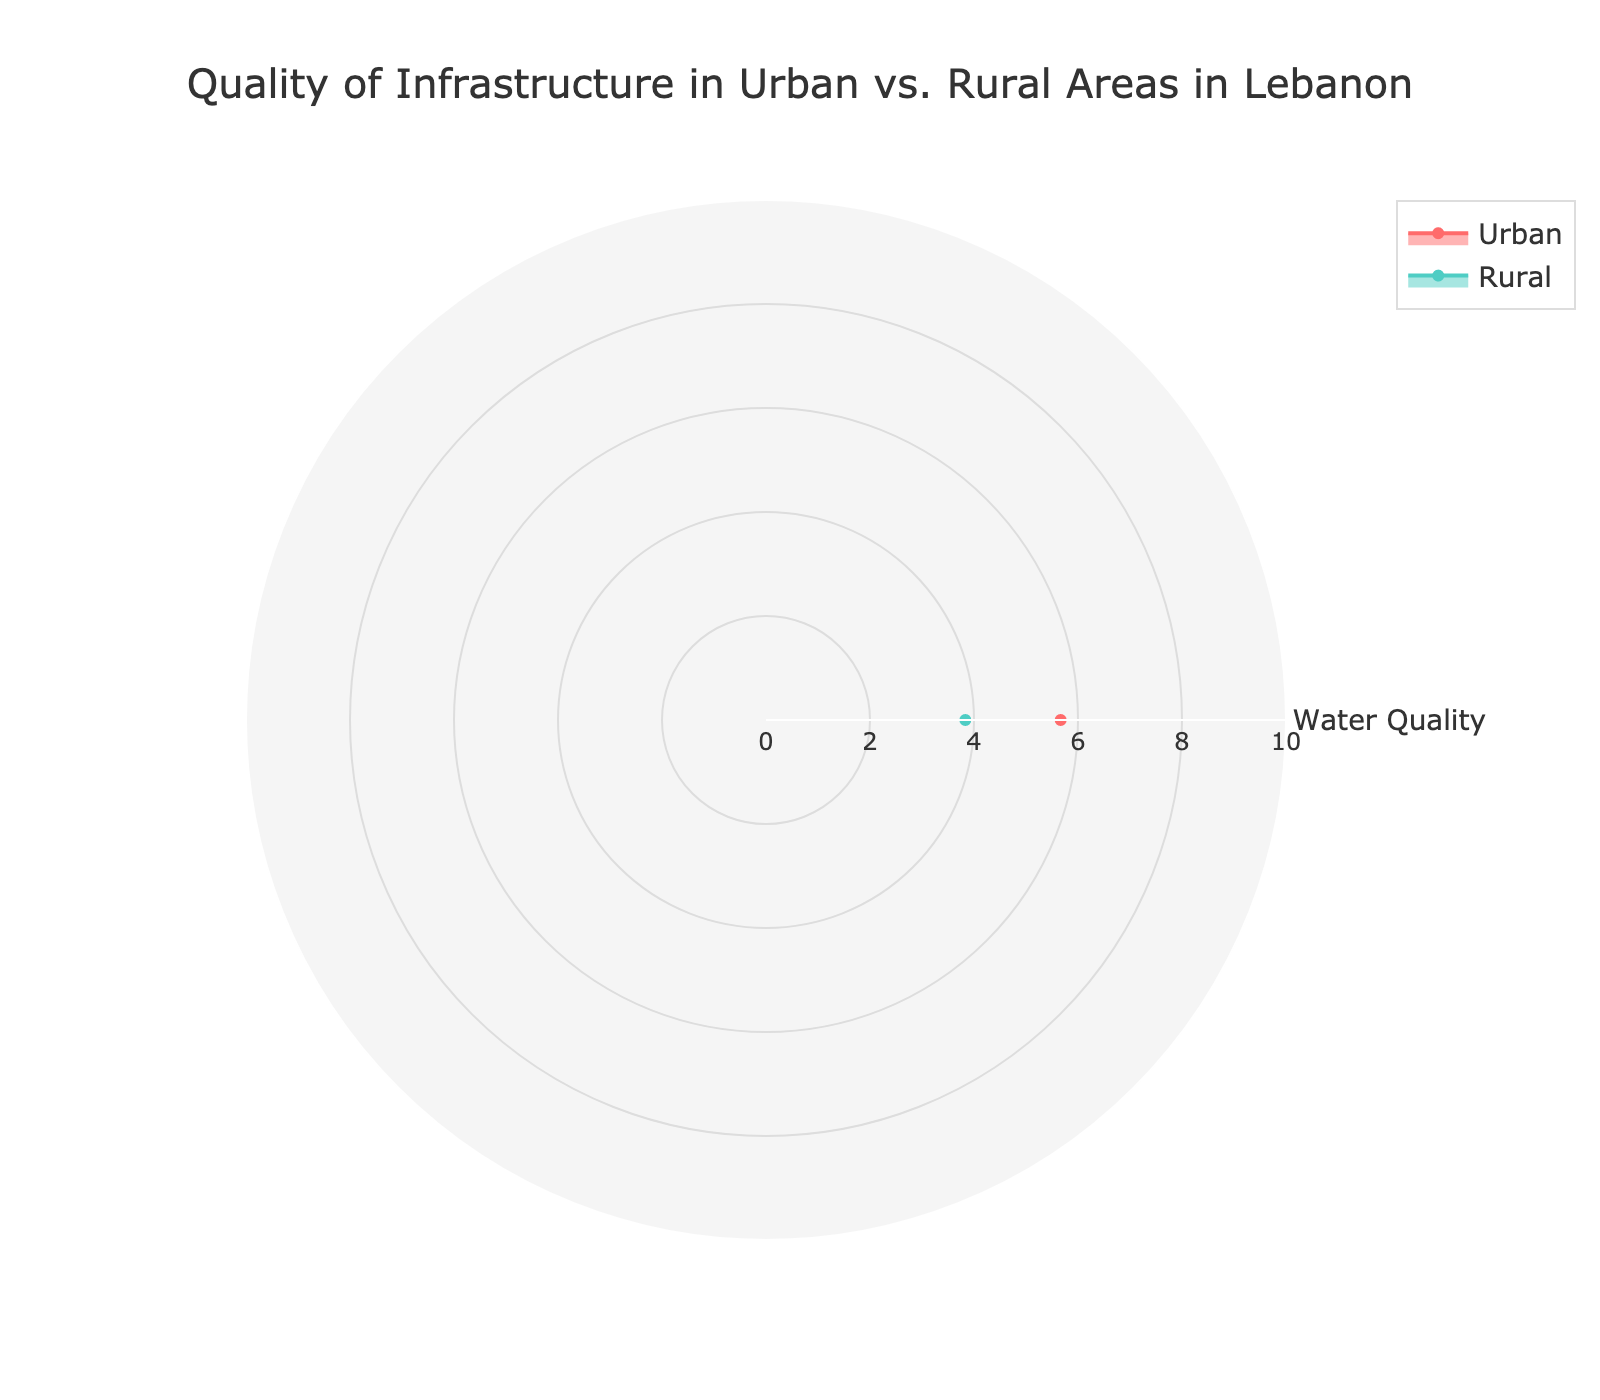What is the title of the figure? The title of the figure is written at the top and specifies what the chart is about, which is "Quality of Infrastructure in Urban vs. Rural Areas in Lebanon".
Answer: Quality of Infrastructure in Urban vs. Rural Areas in Lebanon Which area has the higher average water quality, urban or rural? To determine this, compare the water quality values for urban and rural areas as displayed on the radar chart.
Answer: Urban What is the average Electricity Reliability for rural areas? To find the average, look at the radar chart section for rural areas and note the value indicated for Electricity Reliability.
Answer: 5.83 Which category shows the smallest difference in quality between urban and rural areas? Examine each category (Water Quality, Electricity Reliability, Road Quality) on the radar chart and compare the lengths of the values for urban and rural areas. The smallest difference will be the least noticeable gap.
Answer: Electricity Reliability What is the overall shape of the radar chart for urban areas compared to rural areas? The radar chart's overall shape for each area (urban and rural) can be observed from the filled regions. The urban area's shape extends more widely, indicating generally higher values.
Answer: Urban extends more widely How does the quality of roads in rural areas compare to urban areas? Compare the values on the radar chart under the Road Quality category for both urban and rural areas.
Answer: Worse in rural areas What is the difference between the water quality ratings in Sidon and Bekaa Valley? Note the water quality ratings for Sidon and Bekaa Valley on the radar chart and subtract the Bekaa Valley value from the Sidon value.
Answer: 1.5 How does the electricity reliability in Tripoli compare to that in Akkar? Observe the values for electricity reliability in both Tripoli and Akkar on the radar chart.
Answer: Higher in Tripoli What is the most significant disparity in infrastructure quality between urban and rural areas? Look at all the categories and identify the one with the most noticeable gap between urban and rural areas on the radar chart.
Answer: Road Quality What's the combined average score of Water Quality and Electricity Reliability in rural areas? Add the water quality and electricity reliability values for rural areas and divide by 2 to find the average. Water Quality (5.33) + Electricity Reliability (5.83) = 11.16, and 11.16 / 2 = 5.58.
Answer: 5.58 